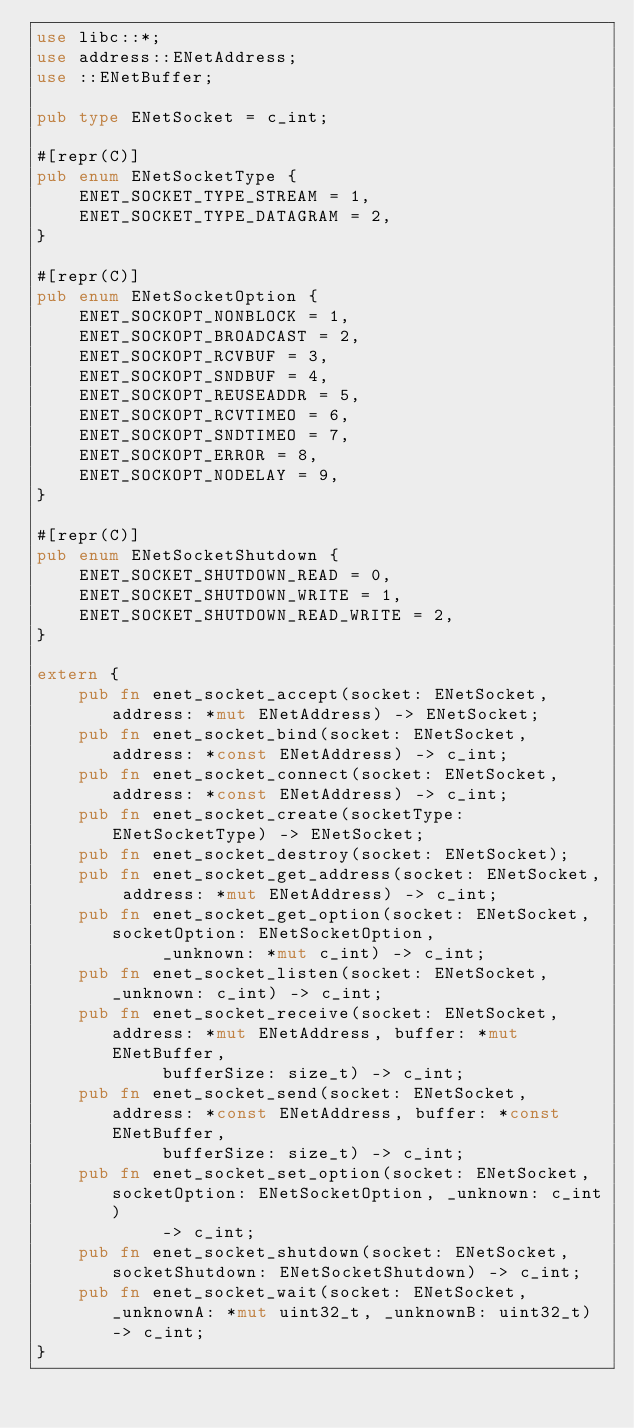<code> <loc_0><loc_0><loc_500><loc_500><_Rust_>use libc::*;
use address::ENetAddress;
use ::ENetBuffer;

pub type ENetSocket = c_int;

#[repr(C)]
pub enum ENetSocketType {
    ENET_SOCKET_TYPE_STREAM = 1,
    ENET_SOCKET_TYPE_DATAGRAM = 2,
}

#[repr(C)]
pub enum ENetSocketOption {
    ENET_SOCKOPT_NONBLOCK = 1,
    ENET_SOCKOPT_BROADCAST = 2,
    ENET_SOCKOPT_RCVBUF = 3,
    ENET_SOCKOPT_SNDBUF = 4,
    ENET_SOCKOPT_REUSEADDR = 5,
    ENET_SOCKOPT_RCVTIMEO = 6,
    ENET_SOCKOPT_SNDTIMEO = 7,
    ENET_SOCKOPT_ERROR = 8,
    ENET_SOCKOPT_NODELAY = 9,
}

#[repr(C)]
pub enum ENetSocketShutdown {
    ENET_SOCKET_SHUTDOWN_READ = 0,
    ENET_SOCKET_SHUTDOWN_WRITE = 1,
    ENET_SOCKET_SHUTDOWN_READ_WRITE = 2,
}

extern {
    pub fn enet_socket_accept(socket: ENetSocket, address: *mut ENetAddress) -> ENetSocket;
    pub fn enet_socket_bind(socket: ENetSocket, address: *const ENetAddress) -> c_int;
    pub fn enet_socket_connect(socket: ENetSocket, address: *const ENetAddress) -> c_int;
    pub fn enet_socket_create(socketType: ENetSocketType) -> ENetSocket;
    pub fn enet_socket_destroy(socket: ENetSocket);
    pub fn enet_socket_get_address(socket: ENetSocket, address: *mut ENetAddress) -> c_int;
    pub fn enet_socket_get_option(socket: ENetSocket, socketOption: ENetSocketOption,
            _unknown: *mut c_int) -> c_int;
    pub fn enet_socket_listen(socket: ENetSocket, _unknown: c_int) -> c_int;
    pub fn enet_socket_receive(socket: ENetSocket, address: *mut ENetAddress, buffer: *mut ENetBuffer,
            bufferSize: size_t) -> c_int;
    pub fn enet_socket_send(socket: ENetSocket, address: *const ENetAddress, buffer: *const ENetBuffer,
            bufferSize: size_t) -> c_int;
    pub fn enet_socket_set_option(socket: ENetSocket, socketOption: ENetSocketOption, _unknown: c_int)
            -> c_int;
    pub fn enet_socket_shutdown(socket: ENetSocket, socketShutdown: ENetSocketShutdown) -> c_int;
    pub fn enet_socket_wait(socket: ENetSocket, _unknownA: *mut uint32_t, _unknownB: uint32_t) -> c_int;
}
</code> 